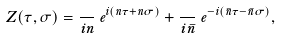Convert formula to latex. <formula><loc_0><loc_0><loc_500><loc_500>Z ( \tau , \sigma ) = \frac { \Lambda } { i n } \, e ^ { i ( n \tau + n \sigma ) } + \frac { \Lambda } { i \bar { n } } \, e ^ { - i ( \bar { n } \tau - \bar { n } \sigma ) } ,</formula> 